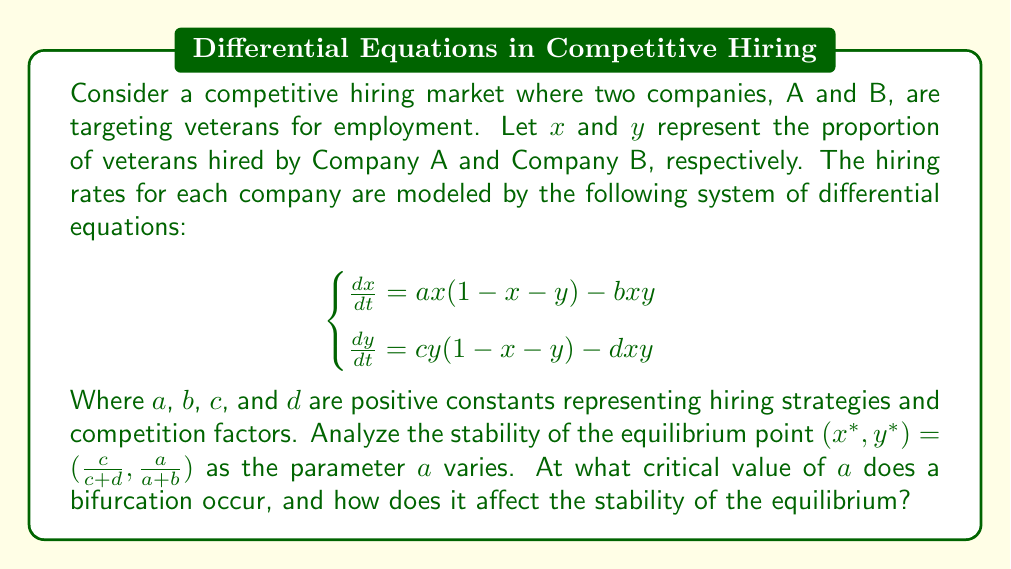Solve this math problem. To analyze the stability of the equilibrium point and identify the bifurcation, we'll follow these steps:

1) First, we need to find the Jacobian matrix of the system at the equilibrium point:

   $$J = \begin{bmatrix}
   \frac{\partial \dot{x}}{\partial x} & \frac{\partial \dot{x}}{\partial y} \\
   \frac{\partial \dot{y}}{\partial x} & \frac{\partial \dot{y}}{\partial y}
   \end{bmatrix}$$

2) Evaluating the partial derivatives:

   $$J = \begin{bmatrix}
   a(1-2x-y) - by & -ax - by \\
   -cy - dx & c(1-x-2y) - dx
   \end{bmatrix}$$

3) Substituting the equilibrium point $(x^*, y^*) = (\frac{c}{c+d}, \frac{a}{a+b})$:

   $$J^* = \begin{bmatrix}
   -a\frac{c}{c+d} - b\frac{a}{a+b} & -a\frac{c}{c+d} - b\frac{a}{a+b} \\
   -c\frac{a}{a+b} - d\frac{c}{c+d} & -c\frac{a}{a+b} - d\frac{c}{c+d}
   \end{bmatrix}$$

4) The characteristic equation is given by $\det(J^* - \lambda I) = 0$:

   $$\lambda^2 + \lambda(a\frac{c}{c+d} + b\frac{a}{a+b} + c\frac{a}{a+b} + d\frac{c}{c+d}) + (a\frac{c}{c+d} + b\frac{a}{a+b})(c\frac{a}{a+b} + d\frac{c}{c+d}) - (a\frac{c}{c+d} + b\frac{a}{a+b})(c\frac{a}{a+b} + d\frac{c}{c+d}) = 0$$

5) This can be simplified to:

   $$\lambda^2 + \lambda(a\frac{c}{c+d} + b\frac{a}{a+b} + c\frac{a}{a+b} + d\frac{c}{c+d}) = 0$$

6) The eigenvalues are:

   $$\lambda_1 = 0$$
   $$\lambda_2 = -(a\frac{c}{c+d} + b\frac{a}{a+b} + c\frac{a}{a+b} + d\frac{c}{c+d})$$

7) A bifurcation occurs when $\lambda_2 = 0$, which happens when:

   $$a\frac{c}{c+d} + b\frac{a}{a+b} + c\frac{a}{a+b} + d\frac{c}{c+d} = 0$$

8) Solving for $a$:

   $$a_{crit} = \frac{d(c+d)}{b(c+d) + c(a+b)}$$

9) When $a < a_{crit}$, $\lambda_2 > 0$, and the equilibrium is unstable.
   When $a > a_{crit}$, $\lambda_2 < 0$, and the equilibrium is stable.

Therefore, a transcritical bifurcation occurs at $a = a_{crit}$, where the stability of the equilibrium changes.
Answer: $a_{crit} = \frac{d(c+d)}{b(c+d) + c(a+b)}$; transcritical bifurcation 